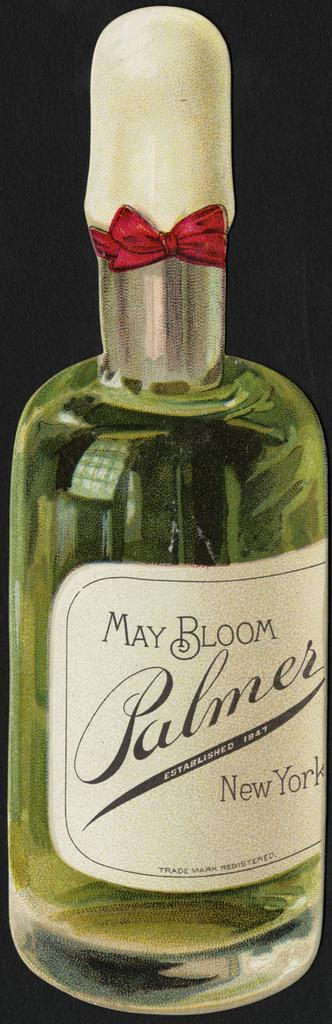<image>
Summarize the visual content of the image. A bottle of May bloom Palmer new york branded alcohol. 